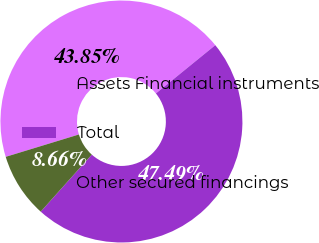<chart> <loc_0><loc_0><loc_500><loc_500><pie_chart><fcel>Assets Financial instruments<fcel>Total<fcel>Other secured financings<nl><fcel>43.85%<fcel>47.49%<fcel>8.66%<nl></chart> 